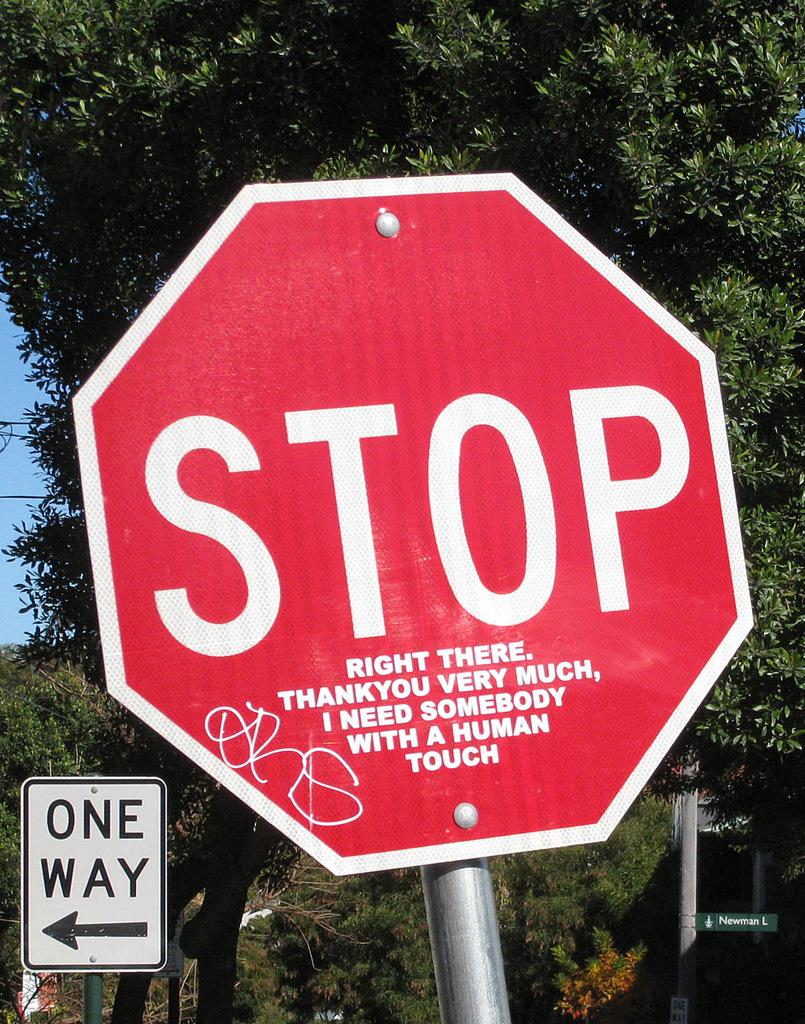<image>
Offer a succinct explanation of the picture presented. A red stop sign has the phrase "right there. Thank you very much, I need somebody with a human touch" written on it. 